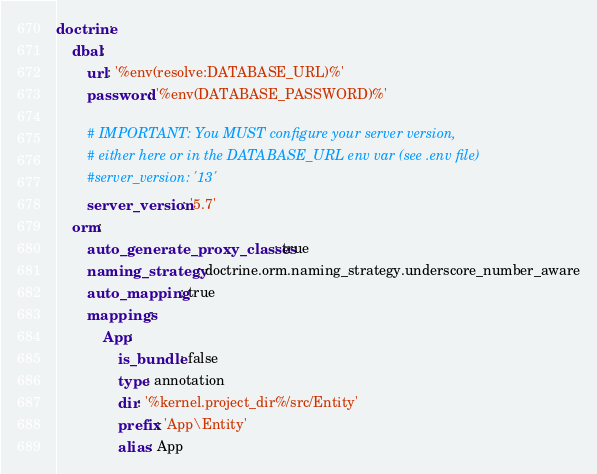<code> <loc_0><loc_0><loc_500><loc_500><_YAML_>doctrine:
    dbal:
        url: '%env(resolve:DATABASE_URL)%'
        password: '%env(DATABASE_PASSWORD)%'

        # IMPORTANT: You MUST configure your server version,
        # either here or in the DATABASE_URL env var (see .env file)
        #server_version: '13'
        server_version: '5.7'
    orm:
        auto_generate_proxy_classes: true
        naming_strategy: doctrine.orm.naming_strategy.underscore_number_aware
        auto_mapping: true
        mappings:
            App:
                is_bundle: false
                type: annotation
                dir: '%kernel.project_dir%/src/Entity'
                prefix: 'App\Entity'
                alias: App
</code> 